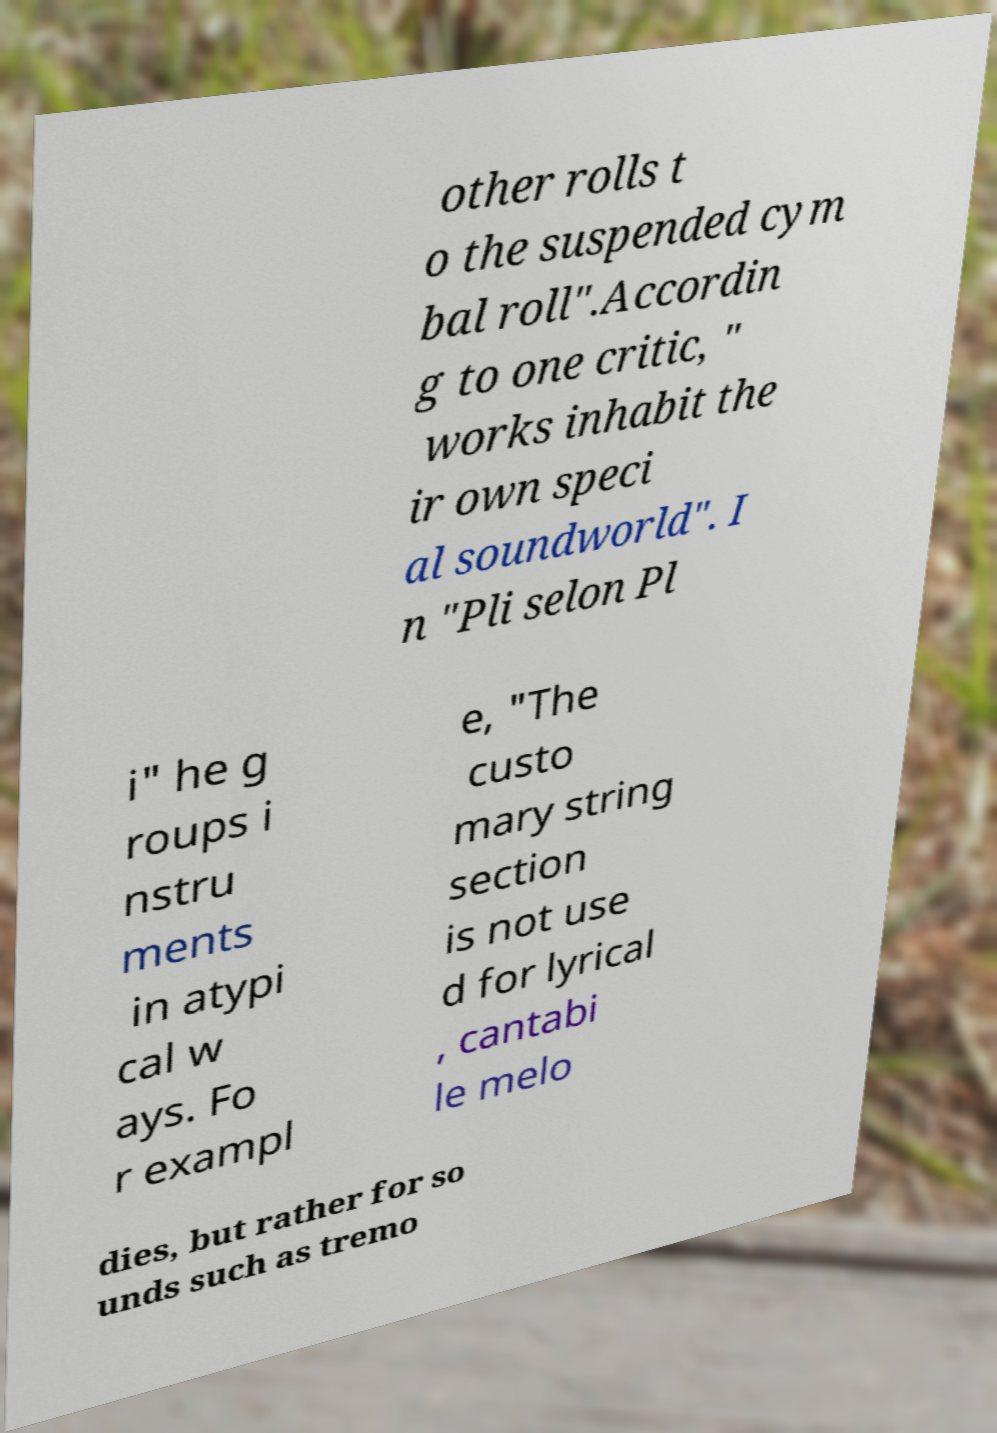Could you extract and type out the text from this image? other rolls t o the suspended cym bal roll".Accordin g to one critic, " works inhabit the ir own speci al soundworld". I n "Pli selon Pl i" he g roups i nstru ments in atypi cal w ays. Fo r exampl e, "The custo mary string section is not use d for lyrical , cantabi le melo dies, but rather for so unds such as tremo 